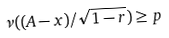<formula> <loc_0><loc_0><loc_500><loc_500>\nu ( ( A - x ) / \sqrt { 1 - r } ) \geq p</formula> 